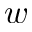<formula> <loc_0><loc_0><loc_500><loc_500>w</formula> 